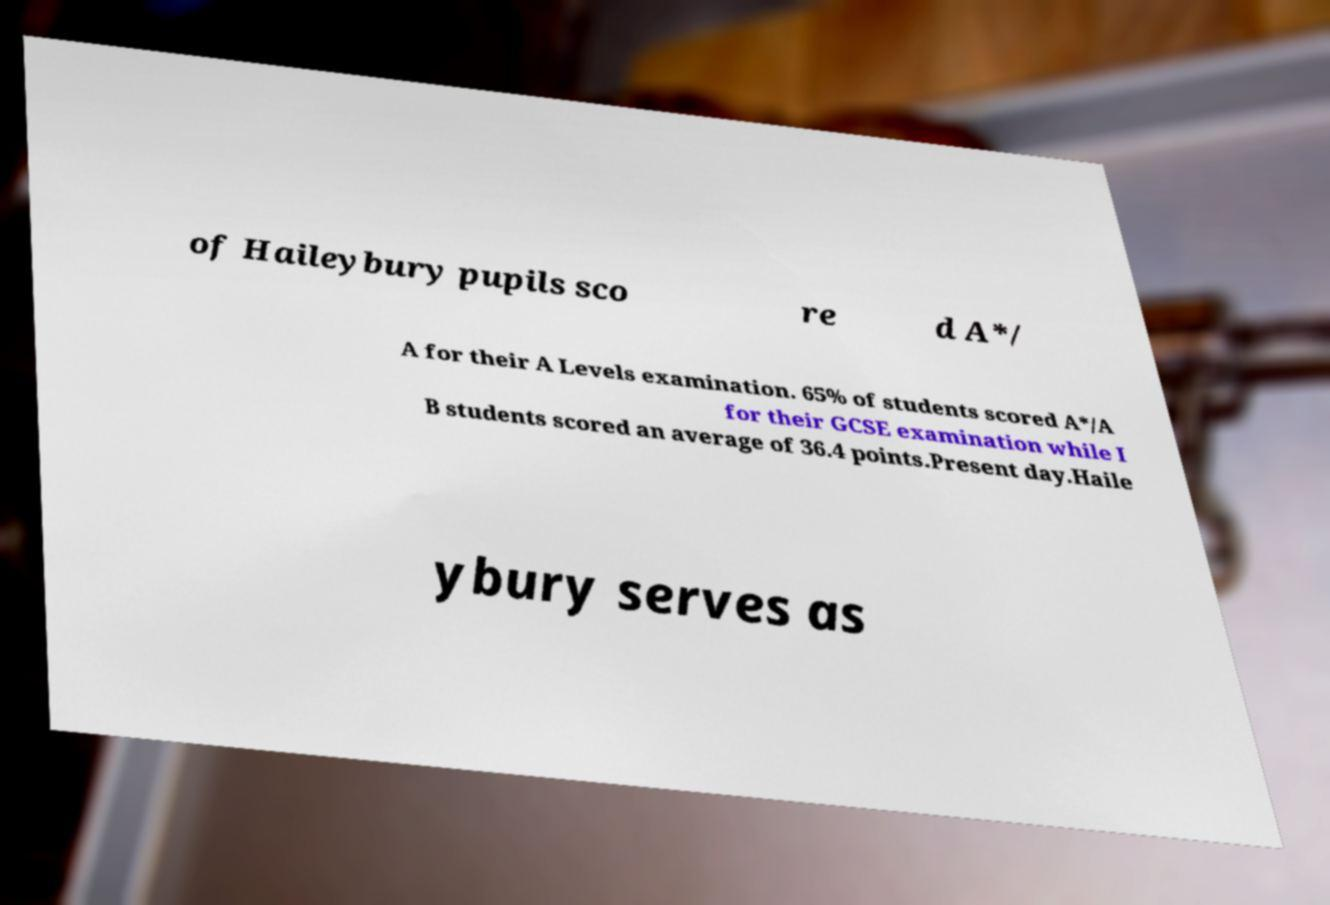There's text embedded in this image that I need extracted. Can you transcribe it verbatim? of Haileybury pupils sco re d A*/ A for their A Levels examination. 65% of students scored A*/A for their GCSE examination while I B students scored an average of 36.4 points.Present day.Haile ybury serves as 